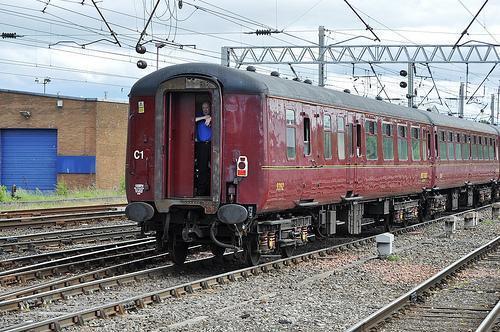How many people are visible?
Give a very brief answer. 1. 